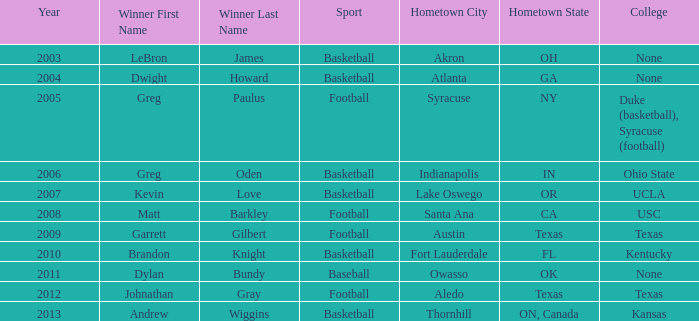What is Winner, when College is "Kentucky"? Brandon Knight. 